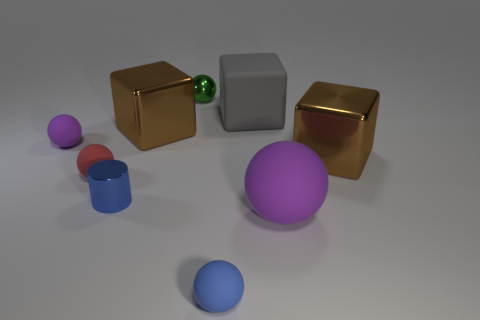How many purple balls must be subtracted to get 1 purple balls? 1 Subtract all large brown shiny cubes. How many cubes are left? 1 Subtract all red spheres. How many spheres are left? 4 Subtract all cyan spheres. Subtract all red cubes. How many spheres are left? 5 Subtract all cylinders. How many objects are left? 8 Subtract 0 gray balls. How many objects are left? 9 Subtract all tiny cyan shiny objects. Subtract all large brown blocks. How many objects are left? 7 Add 2 purple objects. How many purple objects are left? 4 Add 5 cyan matte cylinders. How many cyan matte cylinders exist? 5 